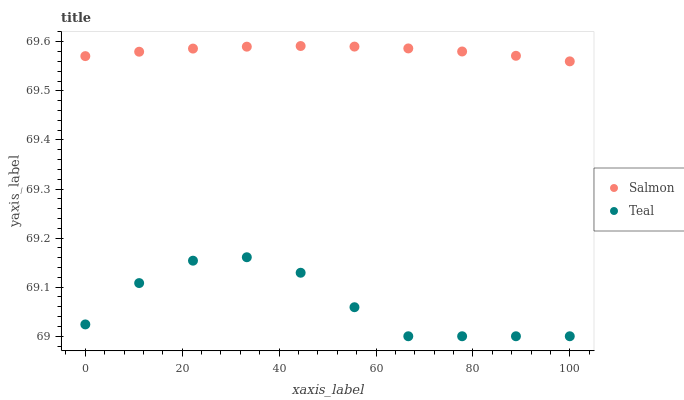Does Teal have the minimum area under the curve?
Answer yes or no. Yes. Does Salmon have the maximum area under the curve?
Answer yes or no. Yes. Does Teal have the maximum area under the curve?
Answer yes or no. No. Is Salmon the smoothest?
Answer yes or no. Yes. Is Teal the roughest?
Answer yes or no. Yes. Is Teal the smoothest?
Answer yes or no. No. Does Teal have the lowest value?
Answer yes or no. Yes. Does Salmon have the highest value?
Answer yes or no. Yes. Does Teal have the highest value?
Answer yes or no. No. Is Teal less than Salmon?
Answer yes or no. Yes. Is Salmon greater than Teal?
Answer yes or no. Yes. Does Teal intersect Salmon?
Answer yes or no. No. 